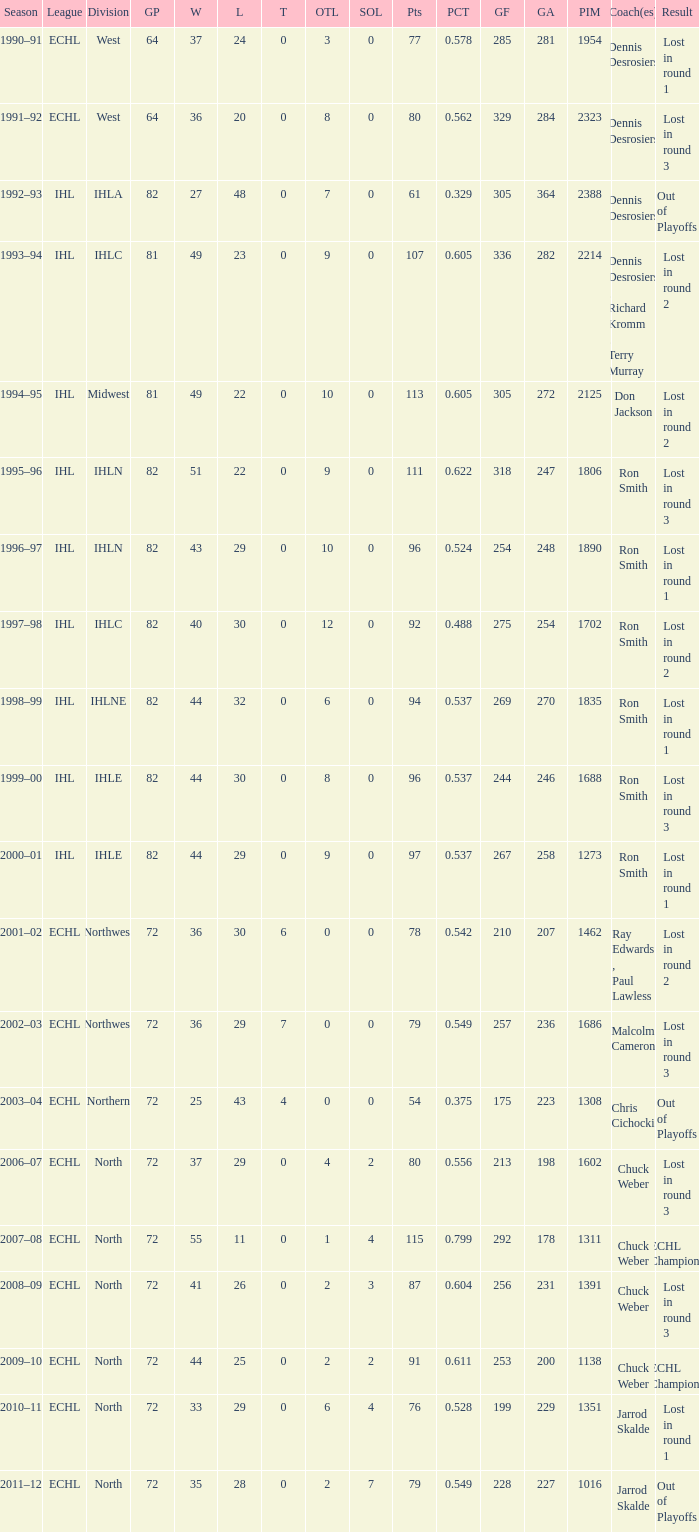In how many seasons did the team suffer a loss in round 1 with a gp of 64? 1.0. 